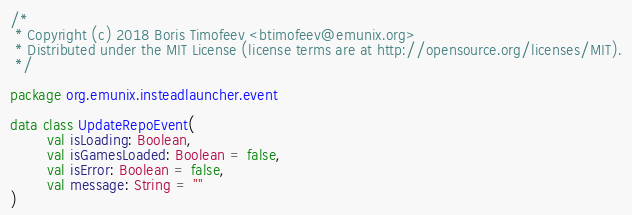Convert code to text. <code><loc_0><loc_0><loc_500><loc_500><_Kotlin_>/*
 * Copyright (c) 2018 Boris Timofeev <btimofeev@emunix.org>
 * Distributed under the MIT License (license terms are at http://opensource.org/licenses/MIT).
 */

package org.emunix.insteadlauncher.event

data class UpdateRepoEvent(
        val isLoading: Boolean,
        val isGamesLoaded: Boolean = false,
        val isError: Boolean = false,
        val message: String = ""
)
</code> 